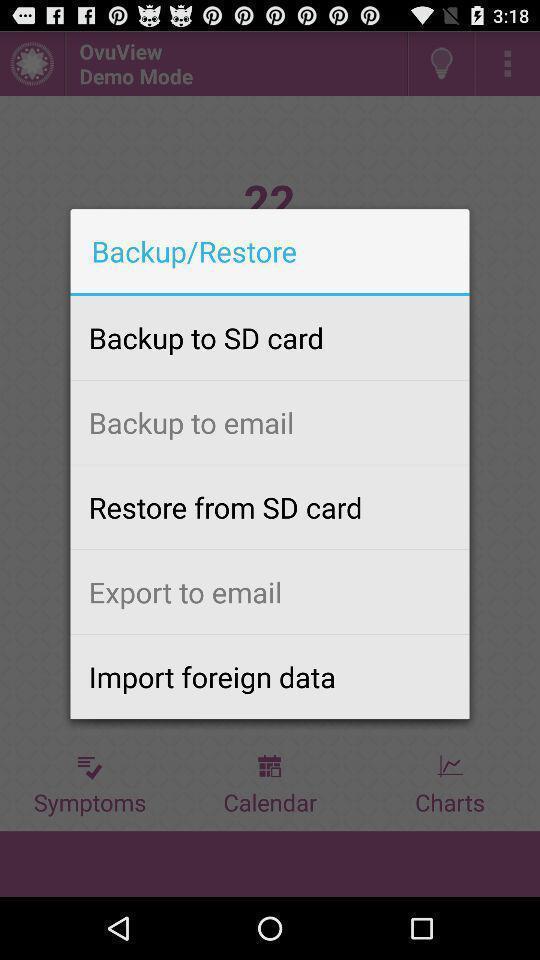Give me a narrative description of this picture. Pop-up to backup or restore. 